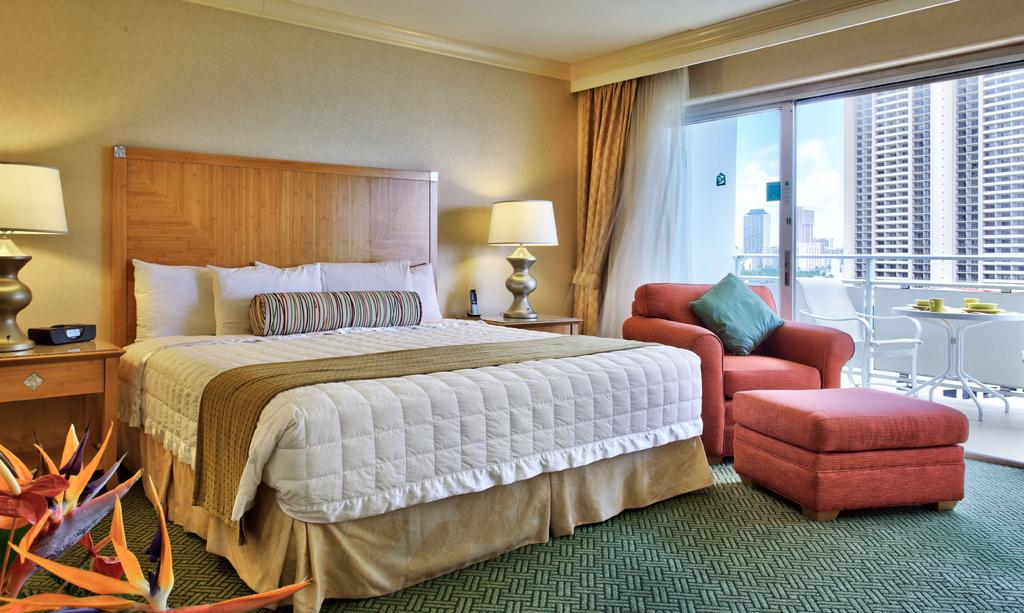What type of furniture is present in the image? There is a bed and a sofa in the image. How many lamps are visible in the image? There are two lamps in the image. What decorative element can be seen in the image? There is a flower in the image. What can be seen outside the room in the image? Buildings and the sky are visible in the image. What type of window treatment is present in the image? There are curtains in the image. How many hands are visible on the bed in the image? There are no hands visible on the bed in the image. What type of account is associated with the flower in the image? There is no account associated with the flower in the image; it is a decorative element. 